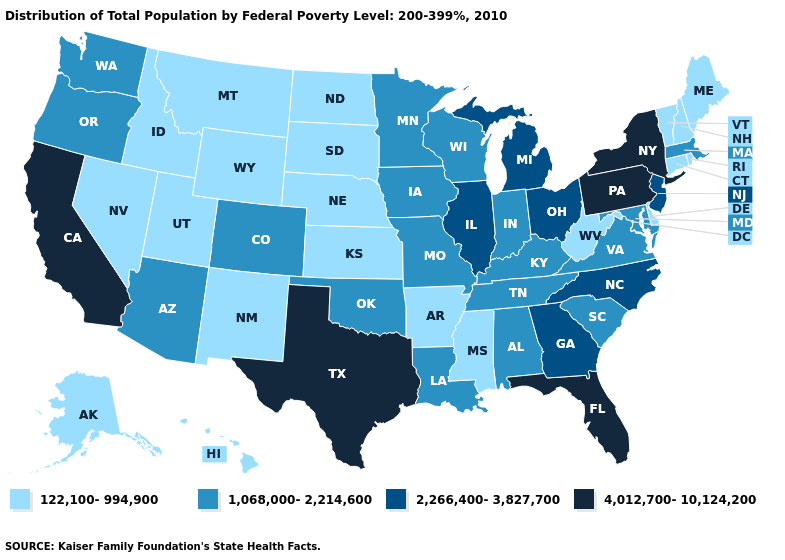Name the states that have a value in the range 1,068,000-2,214,600?
Quick response, please. Alabama, Arizona, Colorado, Indiana, Iowa, Kentucky, Louisiana, Maryland, Massachusetts, Minnesota, Missouri, Oklahoma, Oregon, South Carolina, Tennessee, Virginia, Washington, Wisconsin. Name the states that have a value in the range 1,068,000-2,214,600?
Quick response, please. Alabama, Arizona, Colorado, Indiana, Iowa, Kentucky, Louisiana, Maryland, Massachusetts, Minnesota, Missouri, Oklahoma, Oregon, South Carolina, Tennessee, Virginia, Washington, Wisconsin. What is the lowest value in states that border Indiana?
Quick response, please. 1,068,000-2,214,600. Name the states that have a value in the range 1,068,000-2,214,600?
Be succinct. Alabama, Arizona, Colorado, Indiana, Iowa, Kentucky, Louisiana, Maryland, Massachusetts, Minnesota, Missouri, Oklahoma, Oregon, South Carolina, Tennessee, Virginia, Washington, Wisconsin. Among the states that border Wyoming , does Colorado have the highest value?
Concise answer only. Yes. Which states hav the highest value in the Northeast?
Be succinct. New York, Pennsylvania. What is the value of Maine?
Keep it brief. 122,100-994,900. Which states hav the highest value in the MidWest?
Give a very brief answer. Illinois, Michigan, Ohio. Which states have the lowest value in the South?
Short answer required. Arkansas, Delaware, Mississippi, West Virginia. What is the value of New Hampshire?
Be succinct. 122,100-994,900. Does the map have missing data?
Keep it brief. No. How many symbols are there in the legend?
Quick response, please. 4. Name the states that have a value in the range 122,100-994,900?
Give a very brief answer. Alaska, Arkansas, Connecticut, Delaware, Hawaii, Idaho, Kansas, Maine, Mississippi, Montana, Nebraska, Nevada, New Hampshire, New Mexico, North Dakota, Rhode Island, South Dakota, Utah, Vermont, West Virginia, Wyoming. Name the states that have a value in the range 122,100-994,900?
Give a very brief answer. Alaska, Arkansas, Connecticut, Delaware, Hawaii, Idaho, Kansas, Maine, Mississippi, Montana, Nebraska, Nevada, New Hampshire, New Mexico, North Dakota, Rhode Island, South Dakota, Utah, Vermont, West Virginia, Wyoming. Which states have the lowest value in the USA?
Give a very brief answer. Alaska, Arkansas, Connecticut, Delaware, Hawaii, Idaho, Kansas, Maine, Mississippi, Montana, Nebraska, Nevada, New Hampshire, New Mexico, North Dakota, Rhode Island, South Dakota, Utah, Vermont, West Virginia, Wyoming. 